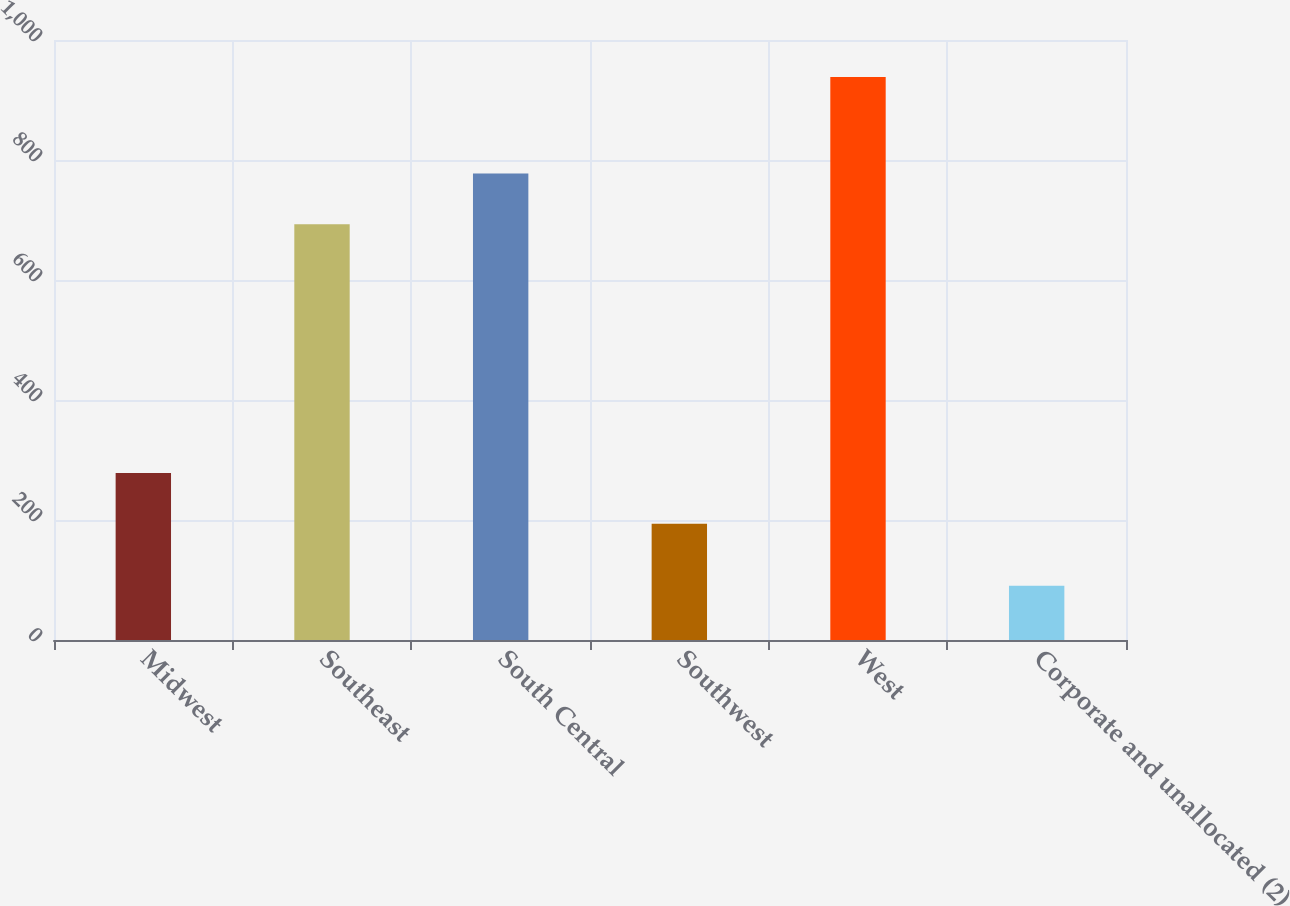Convert chart to OTSL. <chart><loc_0><loc_0><loc_500><loc_500><bar_chart><fcel>Midwest<fcel>Southeast<fcel>South Central<fcel>Southwest<fcel>West<fcel>Corporate and unallocated (2)<nl><fcel>278.39<fcel>692.9<fcel>777.69<fcel>193.6<fcel>938.4<fcel>90.5<nl></chart> 